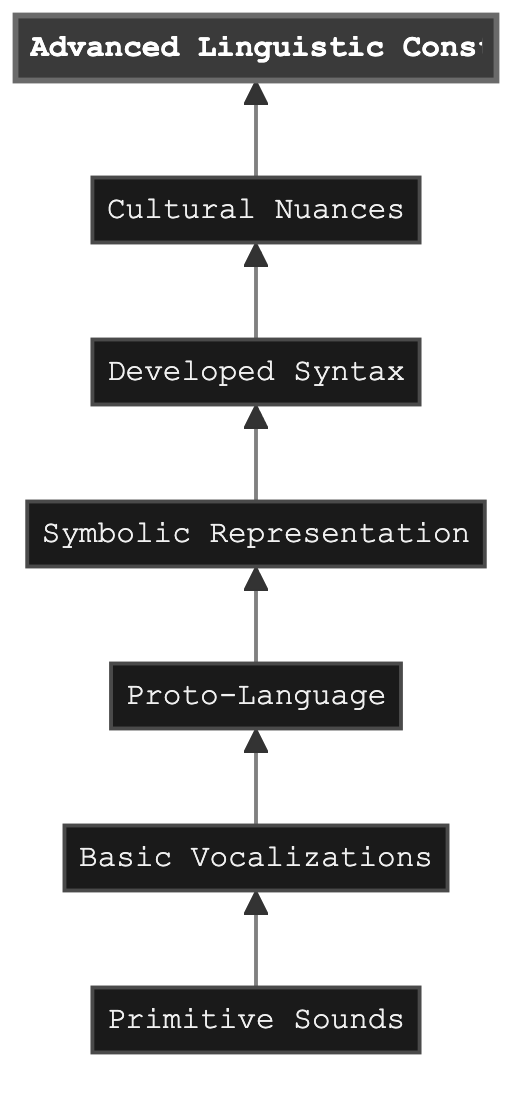What is the highest level of alien language evolution in the diagram? The diagram shows the elements arranged in a flow from bottom to top, with the highest level labeled as "Advanced Linguistic Constructs" at the top of the flow.
Answer: Advanced Linguistic Constructs How many total levels are represented in the diagram? Counting all the nodes listed from Primitive Sounds to Advanced Linguistic Constructs, there are a total of seven levels, which can be verified by listing each one in the flow chart.
Answer: 7 What follows "Symbolic Representation" in the progression of alien language evolution? The diagram illustrates the flow from "Symbolic Representation" leading to the next level, which is labeled "Developed Syntax," so the answer can be found by checking the connection above this node.
Answer: Developed Syntax Which level introduces complex grammatical structures? In the flow chart, the node titled "Developed Syntax" specifies the introduction of complex grammatical structures, indicating this stage in the evolution of alien language specifically addresses this advancement.
Answer: Developed Syntax Which two levels focus most on emotional expression and individuality? The levels "Basic Vocalizations" and "Proto-Language" each contribute to emotional expression and identification; "Basic Vocalizations" develops more nuanced sounds for emotion, while "Proto-Language" introduces grammar rules for complex messaging that can express these aspects.
Answer: Basic Vocalizations and Proto-Language What concept is introduced at the level of "Cultural Nuances"? The flow chart indicates that the level "Cultural Nuances" integrates societal influences, including idioms, slang, and formality levels into language, making it a notable development concerning cultural aspects.
Answer: Cultural nuances What is the relationship between "Proto-Language" and "Symbolic Representation"? The flow demonstrates that "Proto-Language" serves as a direct predecessor leading to "Symbolic Representation," suggesting that the development of basic grammar rules in "Proto-Language" paves the way for the use of symbols and gestures in "Symbolic Representation."
Answer: Proto-Language leads to Symbolic Representation How does language complexity progress from "Basic Vocalizations" to "Advanced Linguistic Constructs"? The diagram illustrates a clear upward flow with five intermediary stages: "Proto-Language," "Symbolic Representation," "Developed Syntax," and "Cultural Nuances," ultimately resulting in "Advanced Linguistic Constructs." This indicates a structured evolution of language complexity through a series of enhancements.
Answer: Five intermediary stages 